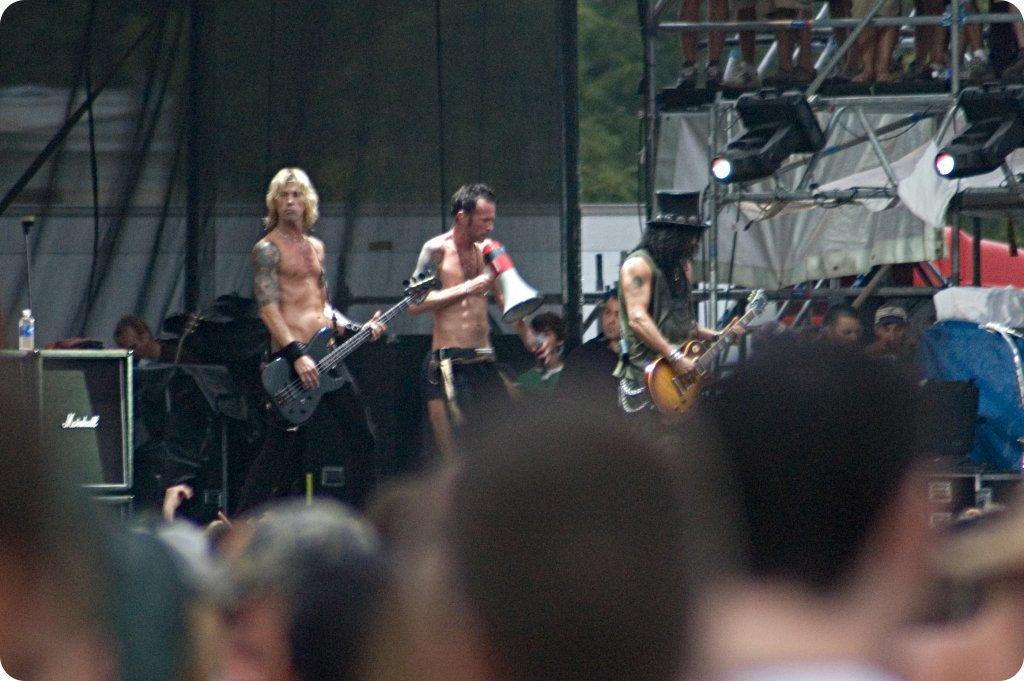Describe this image in one or two sentences. In the center we can see three persons were standing and holding guitar. In the bottom we can see group of persons were standing they were audience. In the background there is tent,tree,lights,table,bottle and few musical instruments. 